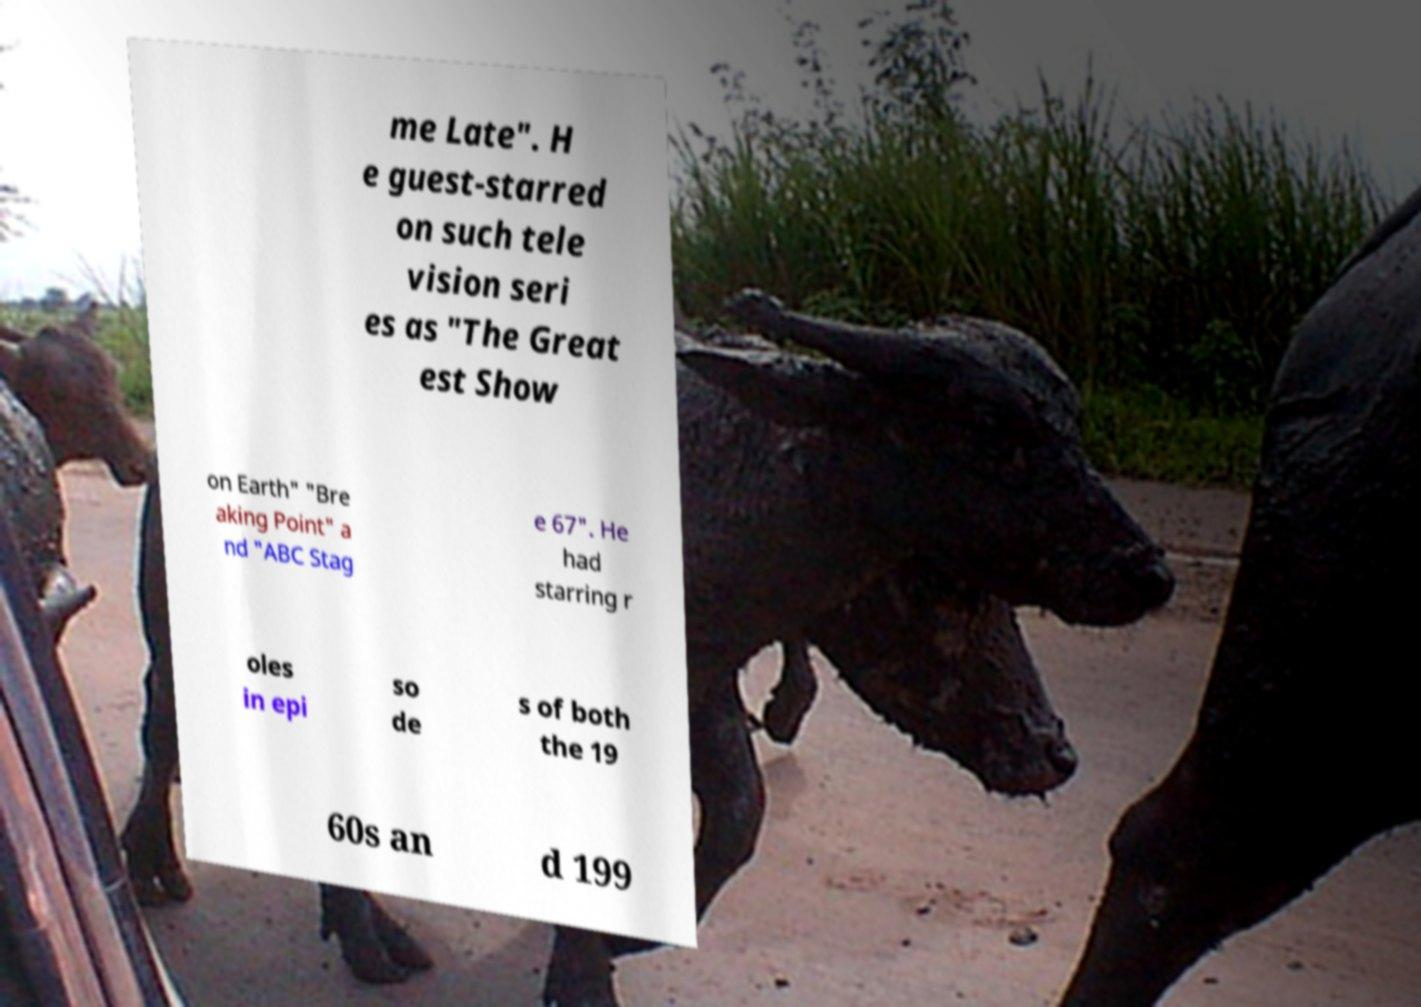Can you accurately transcribe the text from the provided image for me? me Late". H e guest-starred on such tele vision seri es as "The Great est Show on Earth" "Bre aking Point" a nd "ABC Stag e 67". He had starring r oles in epi so de s of both the 19 60s an d 199 